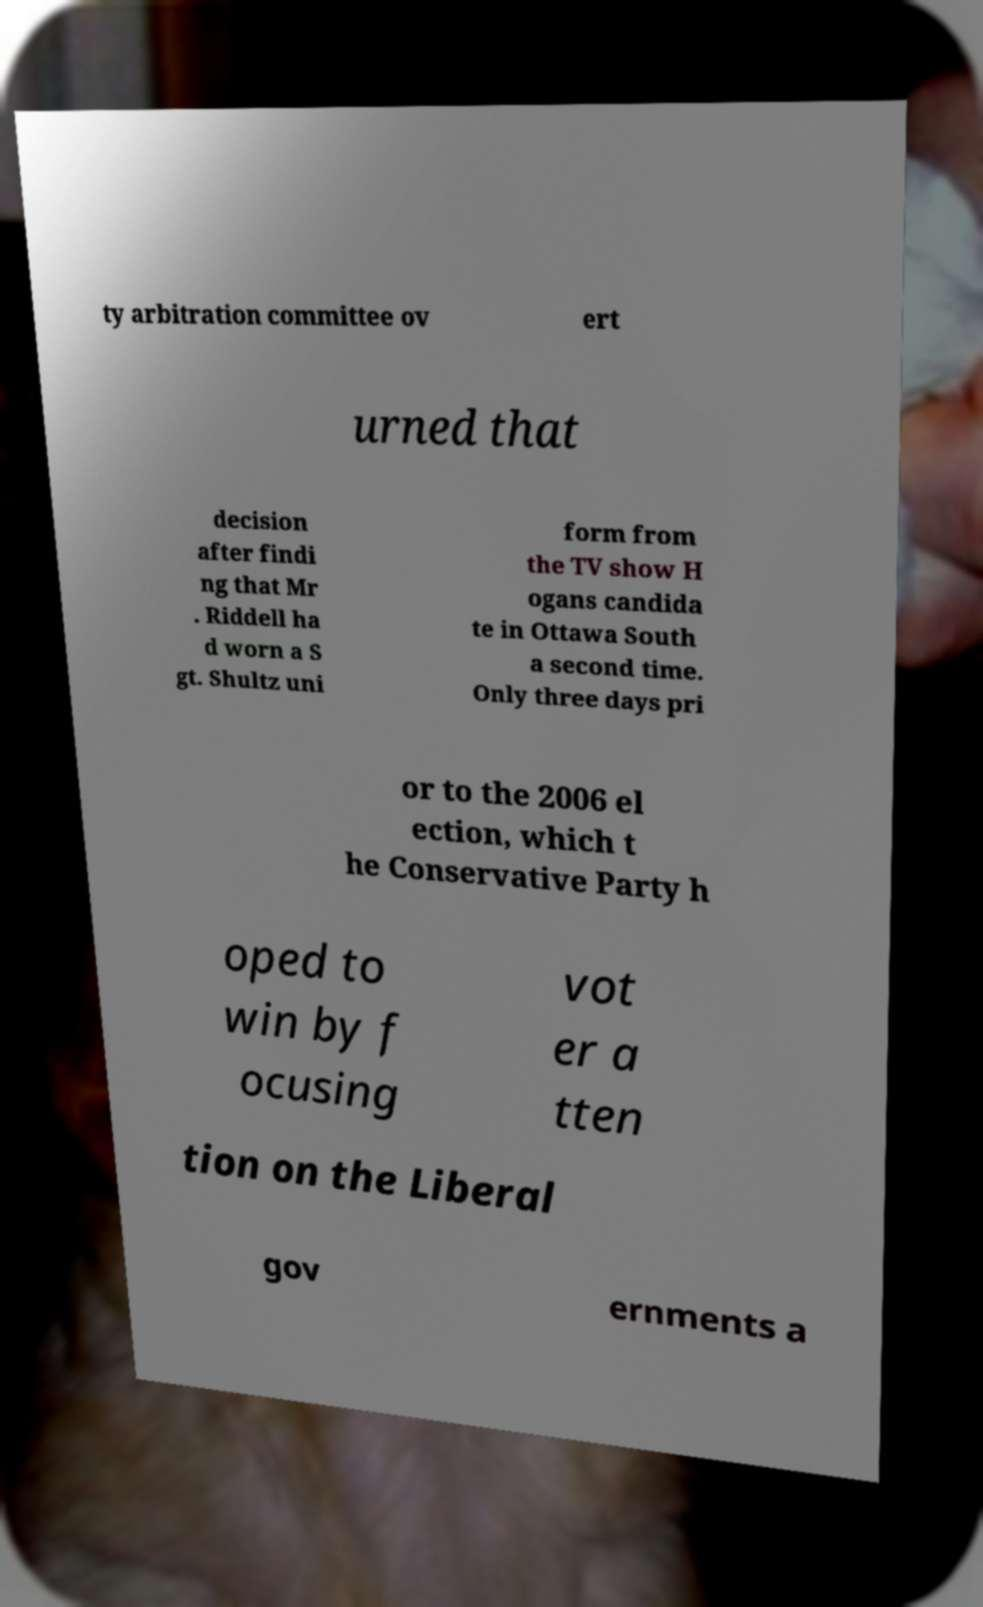What messages or text are displayed in this image? I need them in a readable, typed format. ty arbitration committee ov ert urned that decision after findi ng that Mr . Riddell ha d worn a S gt. Shultz uni form from the TV show H ogans candida te in Ottawa South a second time. Only three days pri or to the 2006 el ection, which t he Conservative Party h oped to win by f ocusing vot er a tten tion on the Liberal gov ernments a 